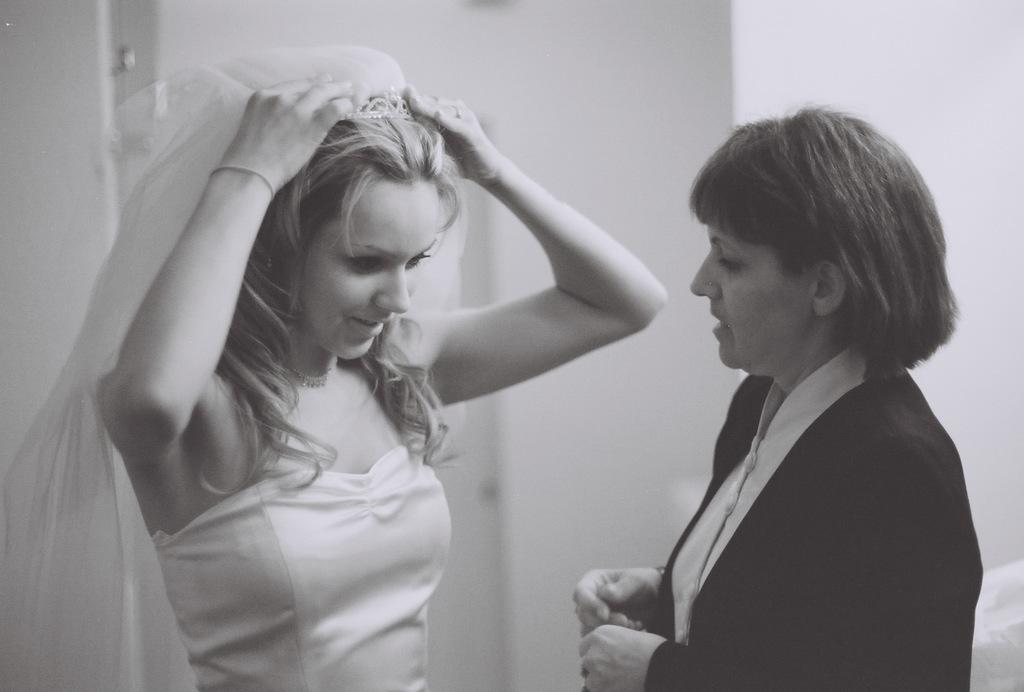Describe this image in one or two sentences. This is a black and white image. Here I can see two women are standing. The woman who is on the right side is looking at the other woman. This woman is holding her crown and looking at the downwards. In the background there is a wall. 